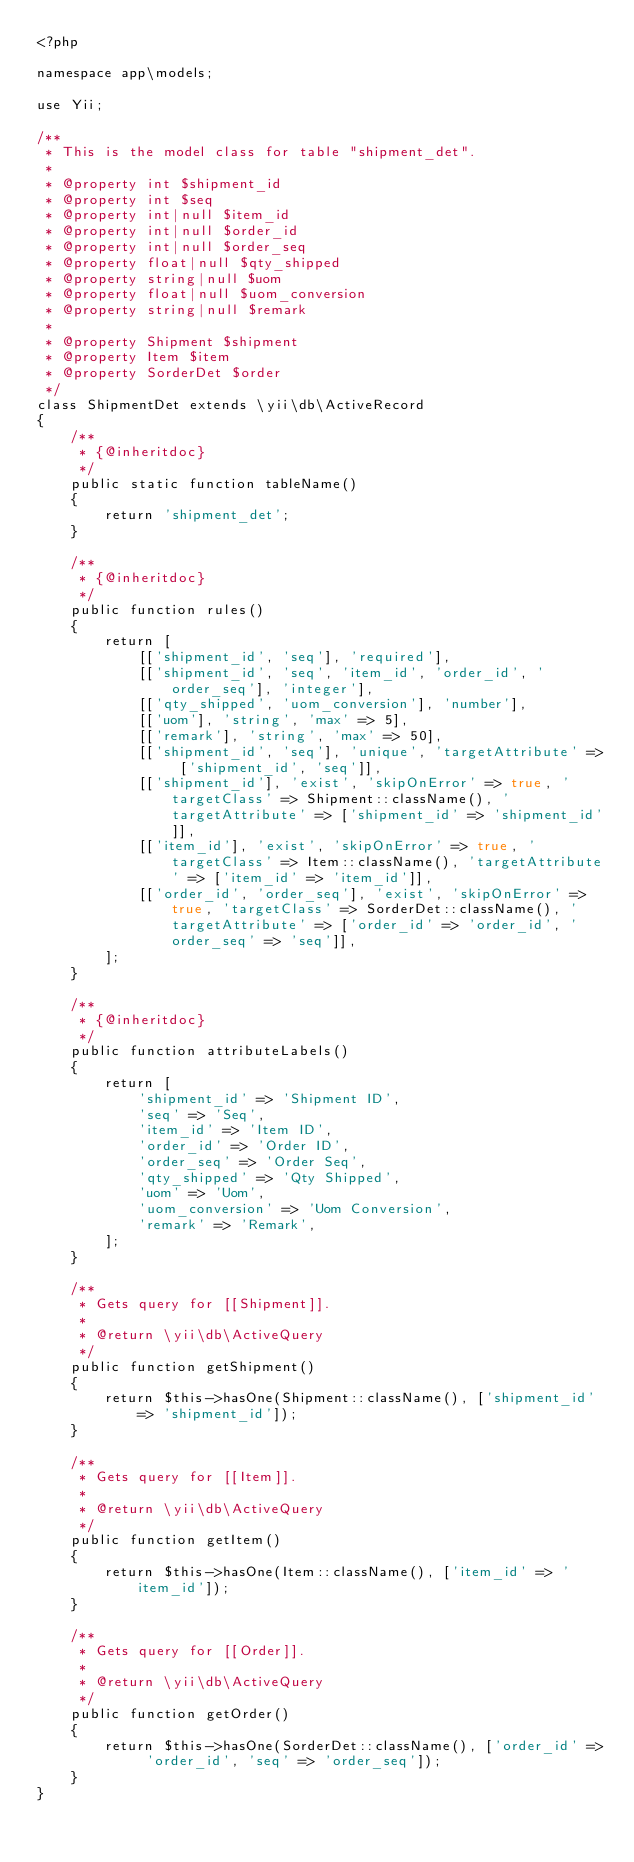Convert code to text. <code><loc_0><loc_0><loc_500><loc_500><_PHP_><?php

namespace app\models;

use Yii;

/**
 * This is the model class for table "shipment_det".
 *
 * @property int $shipment_id
 * @property int $seq
 * @property int|null $item_id
 * @property int|null $order_id
 * @property int|null $order_seq
 * @property float|null $qty_shipped
 * @property string|null $uom
 * @property float|null $uom_conversion
 * @property string|null $remark
 *
 * @property Shipment $shipment
 * @property Item $item
 * @property SorderDet $order
 */
class ShipmentDet extends \yii\db\ActiveRecord
{
    /**
     * {@inheritdoc}
     */
    public static function tableName()
    {
        return 'shipment_det';
    }

    /**
     * {@inheritdoc}
     */
    public function rules()
    {
        return [
            [['shipment_id', 'seq'], 'required'],
            [['shipment_id', 'seq', 'item_id', 'order_id', 'order_seq'], 'integer'],
            [['qty_shipped', 'uom_conversion'], 'number'],
            [['uom'], 'string', 'max' => 5],
            [['remark'], 'string', 'max' => 50],
            [['shipment_id', 'seq'], 'unique', 'targetAttribute' => ['shipment_id', 'seq']],
            [['shipment_id'], 'exist', 'skipOnError' => true, 'targetClass' => Shipment::className(), 'targetAttribute' => ['shipment_id' => 'shipment_id']],
            [['item_id'], 'exist', 'skipOnError' => true, 'targetClass' => Item::className(), 'targetAttribute' => ['item_id' => 'item_id']],
            [['order_id', 'order_seq'], 'exist', 'skipOnError' => true, 'targetClass' => SorderDet::className(), 'targetAttribute' => ['order_id' => 'order_id', 'order_seq' => 'seq']],
        ];
    }

    /**
     * {@inheritdoc}
     */
    public function attributeLabels()
    {
        return [
            'shipment_id' => 'Shipment ID',
            'seq' => 'Seq',
            'item_id' => 'Item ID',
            'order_id' => 'Order ID',
            'order_seq' => 'Order Seq',
            'qty_shipped' => 'Qty Shipped',
            'uom' => 'Uom',
            'uom_conversion' => 'Uom Conversion',
            'remark' => 'Remark',
        ];
    }

    /**
     * Gets query for [[Shipment]].
     *
     * @return \yii\db\ActiveQuery
     */
    public function getShipment()
    {
        return $this->hasOne(Shipment::className(), ['shipment_id' => 'shipment_id']);
    }

    /**
     * Gets query for [[Item]].
     *
     * @return \yii\db\ActiveQuery
     */
    public function getItem()
    {
        return $this->hasOne(Item::className(), ['item_id' => 'item_id']);
    }

    /**
     * Gets query for [[Order]].
     *
     * @return \yii\db\ActiveQuery
     */
    public function getOrder()
    {
        return $this->hasOne(SorderDet::className(), ['order_id' => 'order_id', 'seq' => 'order_seq']);
    }
}
</code> 